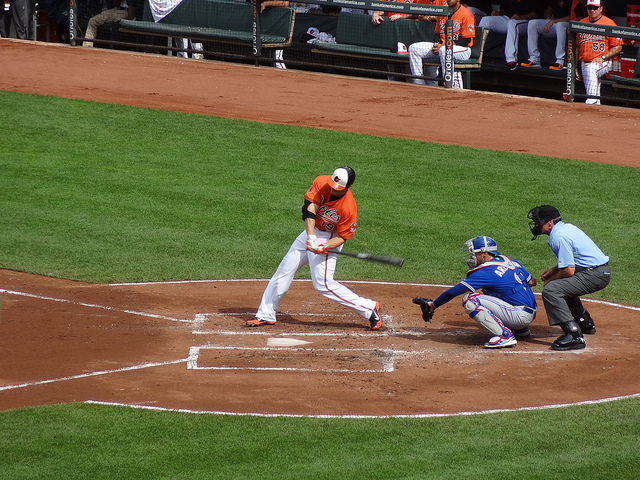Can you describe the uniforms? Certainly, the batter is wearing an orange jersey with white pants, which is typically the home team color, while the catcher wears a blue jersey with gray pants, often indicative of the away team. 